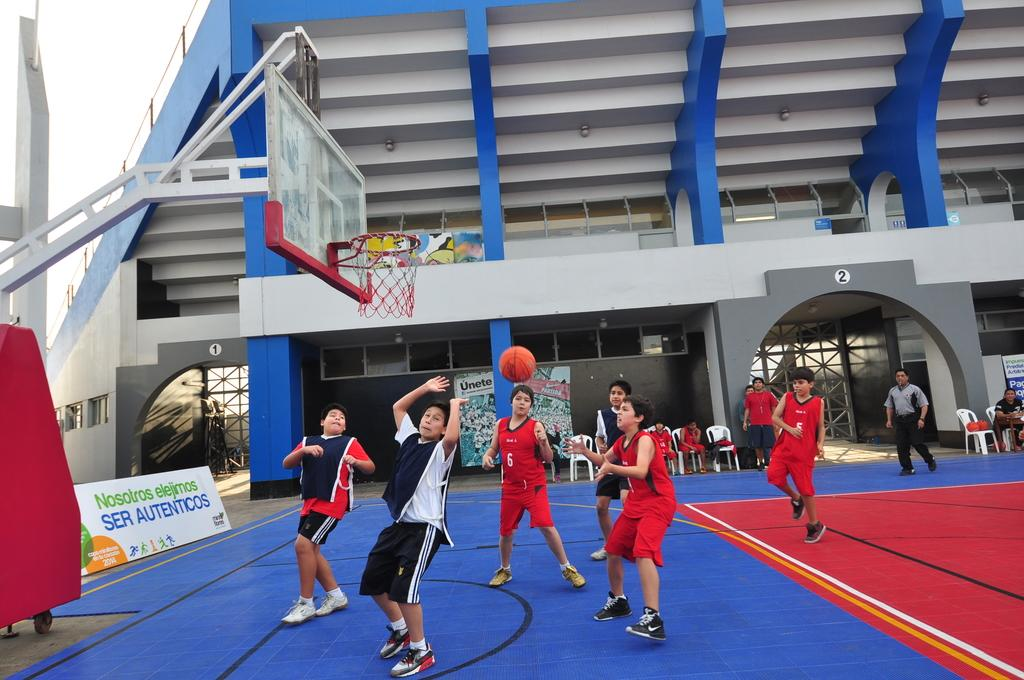What are the persons in the image doing? The persons in the image are playing on the ground. What objects can be seen in the image besides the persons? There are boards, chairs, and a basketball goal in the image. What type of structure is visible in the image? There is a building in the image. What is visible in the background of the image? The sky is visible in the image. What organization does the manager of the basketball team in the image belong to? There is no manager or basketball team mentioned in the image; it simply shows persons playing on the ground with a basketball goal. Can you describe the wave pattern in the image? There is no wave pattern present in the image. 